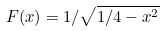Convert formula to latex. <formula><loc_0><loc_0><loc_500><loc_500>F ( x ) = 1 / \sqrt { 1 / 4 - x ^ { 2 } }</formula> 